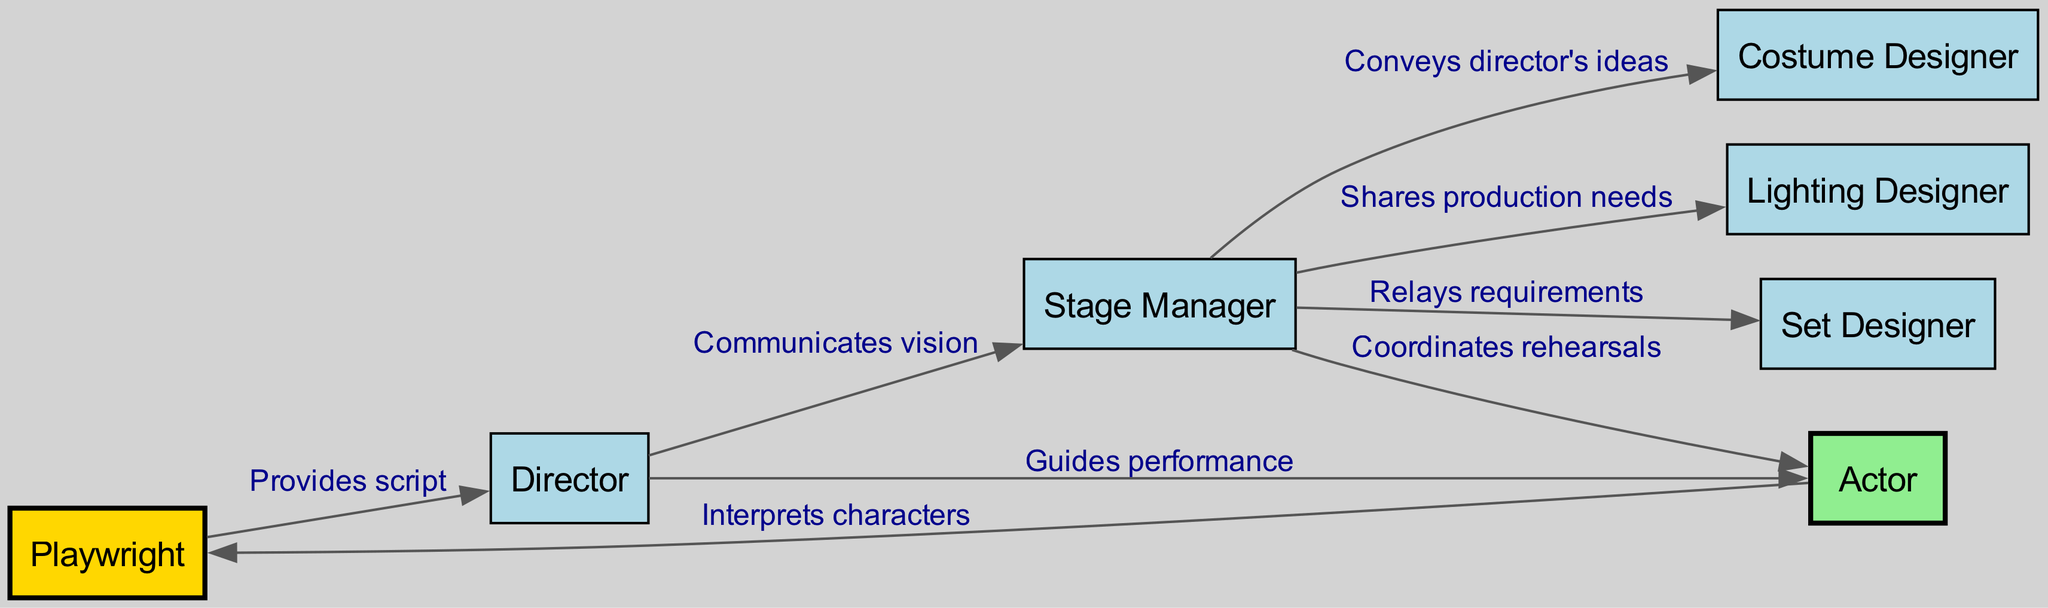What is the role that provides the script? The diagram indicates that the playwright is the role that provides the script to the director. This is a straightforward connection shown by a directed edge labeled "Provides script."
Answer: Playwright How many nodes are there in the diagram? By counting the nodes mentioned in the data, we see there are a total of 7 nodes: playwright, director, actor, stage manager, set designer, costume designer, and lighting designer.
Answer: 7 Who does the director guide in their performance? According to the diagram, the director guides the actor in their performance. This connection is represented by the directed edge labeled "Guides performance."
Answer: Actor What does the stage manager coordinate with? The stage manager coordinates rehearsals with the actor. This relationship is depicted by the directed edge labeled "Coordinates rehearsals."
Answer: Actor What role shares production needs with the lighting designer? Looking at the connections, the stage manager shares production needs with the lighting designer. This is evident from the directed edge labeled "Shares production needs."
Answer: Stage Manager What is the relationship between the actor and the playwright? The actor interprets characters as per the playwright's script. This relationship is depicted by the directed edge labeled "Interprets characters" pointing from the actor to the playwright.
Answer: Interprets characters Which role conveys the director's ideas? The stage manager conveys the director's ideas to the costume designer, as indicated by the directed edge labeled "Conveys director's ideas."
Answer: Costume Designer How many edges connect the playwright to the director? There is only one edge connecting the playwright to the director, which is labeled "Provides script." Therefore, we observe that the connection is singular.
Answer: 1 What role communicates the director's vision to the stage manager? The director communicates their vision to the stage manager. This relationship is indicated by the directed edge labeled "Communicates vision."
Answer: Director 